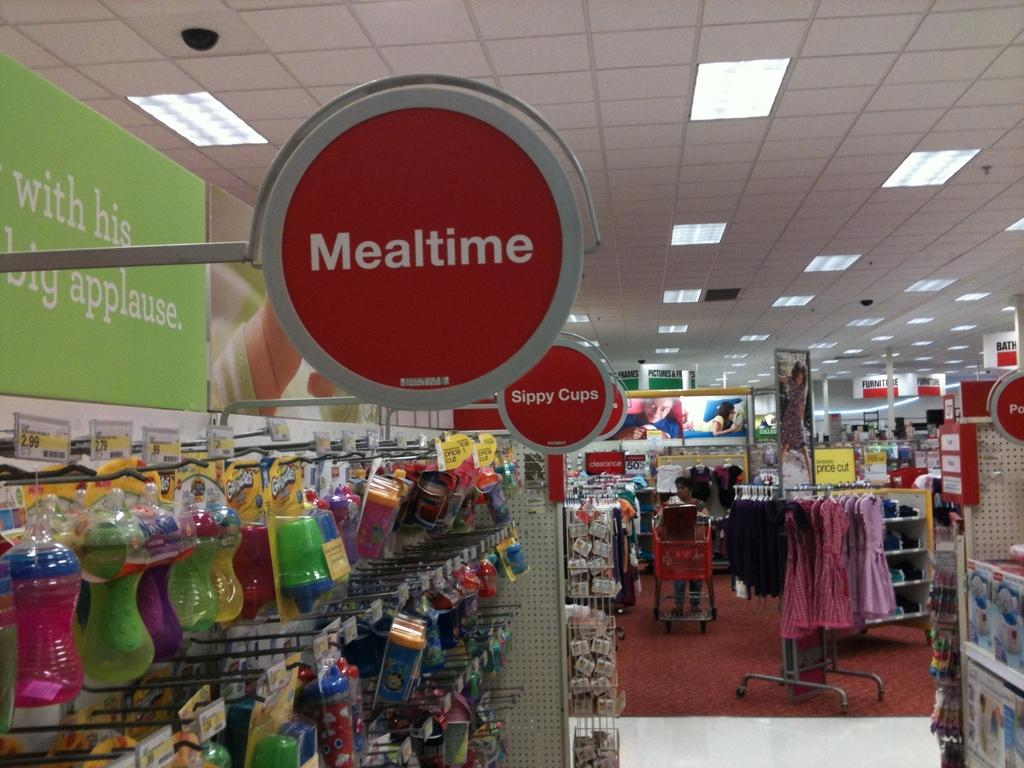<image>
Share a concise interpretation of the image provided. An aisle in a store that has signs that say mealtime an sippy cups 